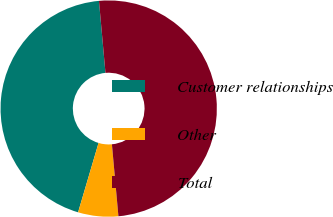Convert chart. <chart><loc_0><loc_0><loc_500><loc_500><pie_chart><fcel>Customer relationships<fcel>Other<fcel>Total<nl><fcel>44.0%<fcel>6.0%<fcel>50.0%<nl></chart> 